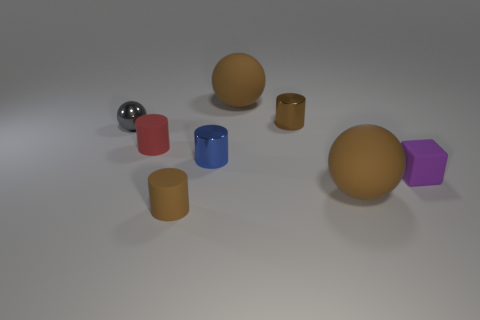The small brown thing that is in front of the small matte block has what shape?
Keep it short and to the point. Cylinder. How many brown rubber spheres are left of the brown cylinder on the right side of the small rubber cylinder that is in front of the small red rubber object?
Keep it short and to the point. 1. Is the size of the shiny sphere the same as the sphere that is in front of the red object?
Your response must be concise. No. What size is the cylinder that is to the left of the small brown thing that is in front of the tiny blue cylinder?
Your answer should be very brief. Small. What number of big things are made of the same material as the tiny purple cube?
Your answer should be compact. 2. Are there any blue objects?
Offer a very short reply. Yes. What is the size of the metal cylinder that is in front of the tiny gray thing?
Keep it short and to the point. Small. How many rubber cylinders are the same color as the small rubber block?
Ensure brevity in your answer.  0. How many cylinders are tiny purple objects or brown metal things?
Your response must be concise. 1. The small metal object that is both behind the blue cylinder and on the right side of the shiny sphere has what shape?
Provide a succinct answer. Cylinder. 